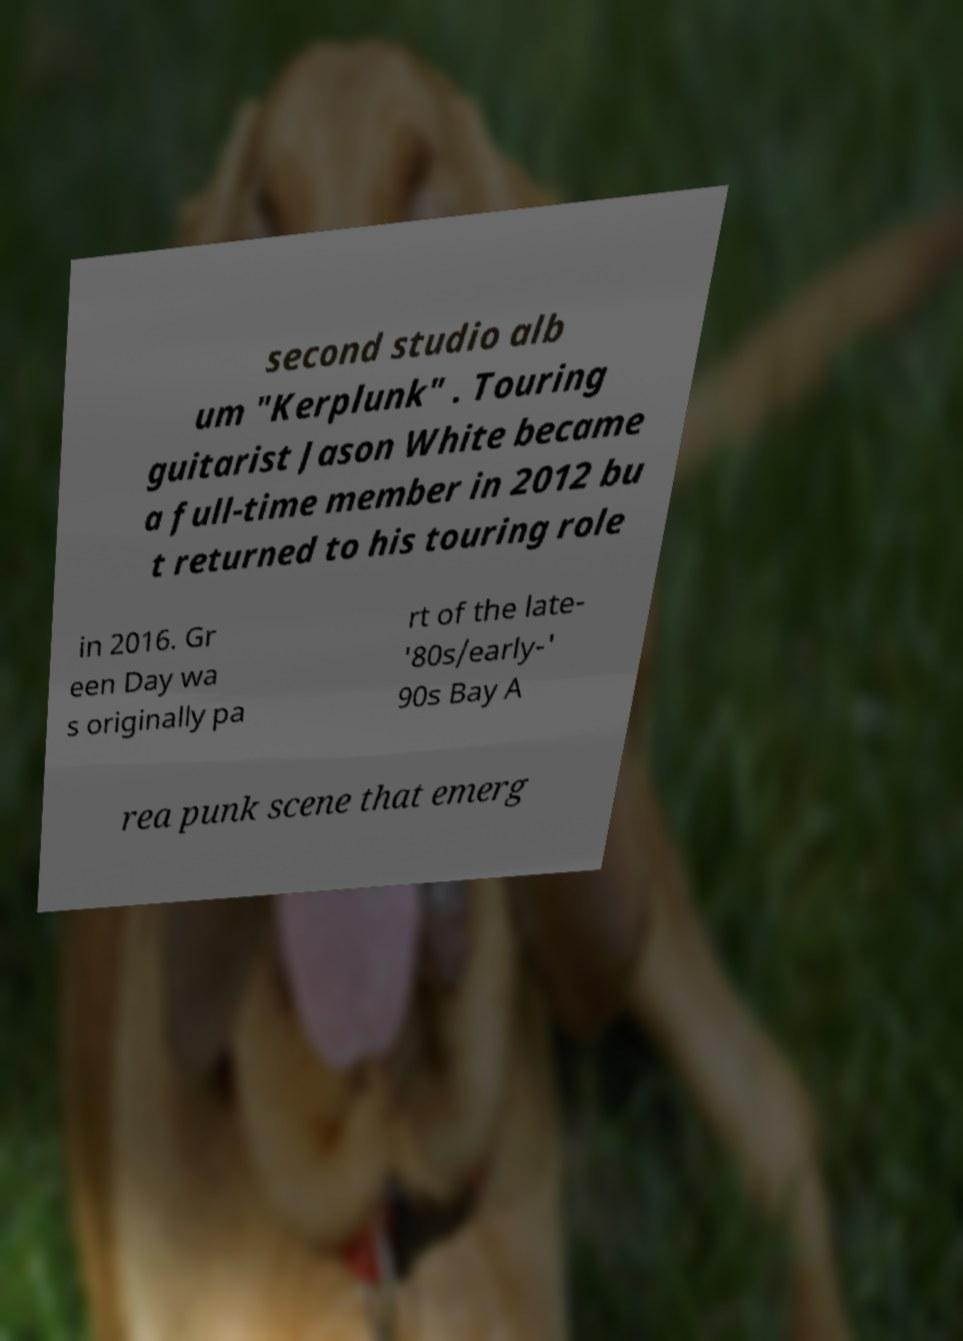Could you assist in decoding the text presented in this image and type it out clearly? second studio alb um "Kerplunk" . Touring guitarist Jason White became a full-time member in 2012 bu t returned to his touring role in 2016. Gr een Day wa s originally pa rt of the late- '80s/early-' 90s Bay A rea punk scene that emerg 